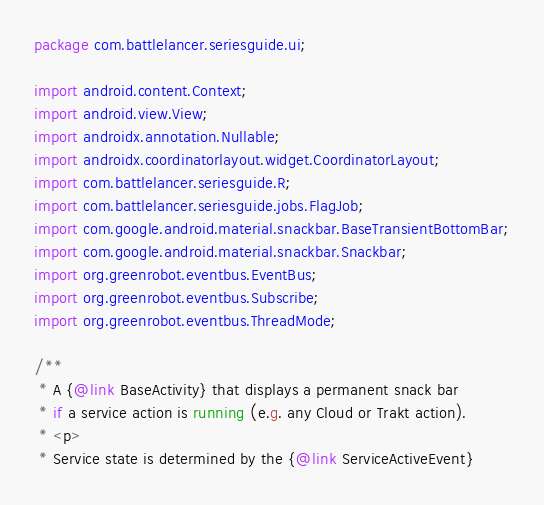Convert code to text. <code><loc_0><loc_0><loc_500><loc_500><_Java_>package com.battlelancer.seriesguide.ui;

import android.content.Context;
import android.view.View;
import androidx.annotation.Nullable;
import androidx.coordinatorlayout.widget.CoordinatorLayout;
import com.battlelancer.seriesguide.R;
import com.battlelancer.seriesguide.jobs.FlagJob;
import com.google.android.material.snackbar.BaseTransientBottomBar;
import com.google.android.material.snackbar.Snackbar;
import org.greenrobot.eventbus.EventBus;
import org.greenrobot.eventbus.Subscribe;
import org.greenrobot.eventbus.ThreadMode;

/**
 * A {@link BaseActivity} that displays a permanent snack bar
 * if a service action is running (e.g. any Cloud or Trakt action).
 * <p>
 * Service state is determined by the {@link ServiceActiveEvent}</code> 